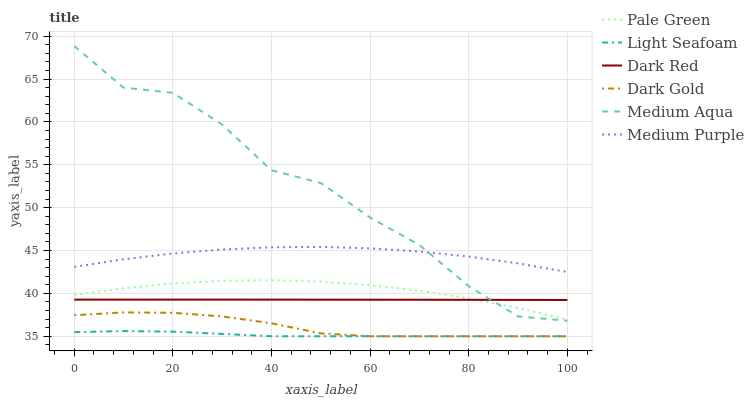Does Light Seafoam have the minimum area under the curve?
Answer yes or no. Yes. Does Medium Aqua have the maximum area under the curve?
Answer yes or no. Yes. Does Dark Red have the minimum area under the curve?
Answer yes or no. No. Does Dark Red have the maximum area under the curve?
Answer yes or no. No. Is Dark Red the smoothest?
Answer yes or no. Yes. Is Medium Aqua the roughest?
Answer yes or no. Yes. Is Medium Purple the smoothest?
Answer yes or no. No. Is Medium Purple the roughest?
Answer yes or no. No. Does Dark Gold have the lowest value?
Answer yes or no. Yes. Does Dark Red have the lowest value?
Answer yes or no. No. Does Medium Aqua have the highest value?
Answer yes or no. Yes. Does Dark Red have the highest value?
Answer yes or no. No. Is Dark Gold less than Medium Purple?
Answer yes or no. Yes. Is Medium Purple greater than Light Seafoam?
Answer yes or no. Yes. Does Dark Gold intersect Light Seafoam?
Answer yes or no. Yes. Is Dark Gold less than Light Seafoam?
Answer yes or no. No. Is Dark Gold greater than Light Seafoam?
Answer yes or no. No. Does Dark Gold intersect Medium Purple?
Answer yes or no. No. 